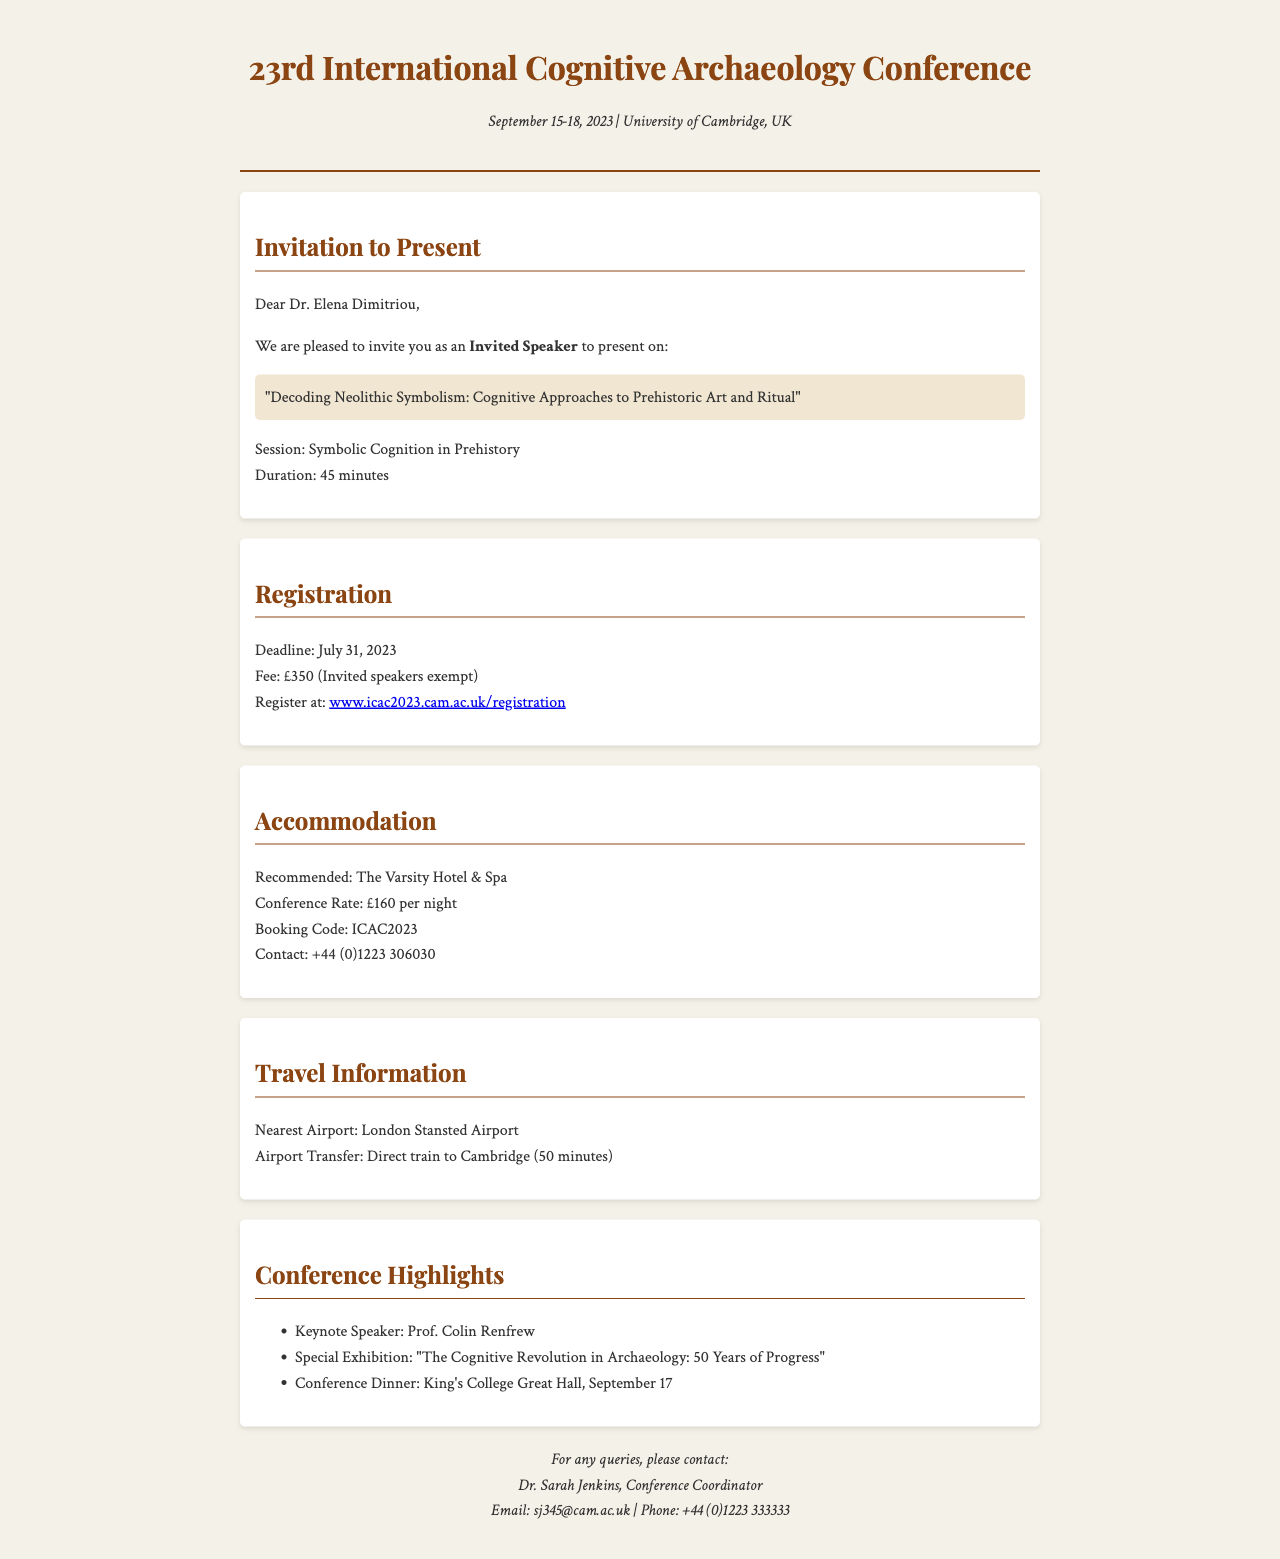What are the conference dates? The conference dates are specified in the document, which mentions September 15-18, 2023.
Answer: September 15-18, 2023 Who is invited to present at the conference? The document addresses an invitation to Dr. Elena Dimitriou, indicating she is the invited speaker.
Answer: Dr. Elena Dimitriou What is the title of the presentation? The document highlights the presentation title associated with the invited speaker, which is "Decoding Neolithic Symbolism: Cognitive Approaches to Prehistoric Art and Ritual".
Answer: Decoding Neolithic Symbolism: Cognitive Approaches to Prehistoric Art and Ritual What is the deadline for registration? The registration deadline is clearly stated in the document as July 31, 2023.
Answer: July 31, 2023 What is the conference rate for accommodation? The document mentions the conference rate for the recommended accommodation, which is £160 per night.
Answer: £160 per night How long is the presentation duration? The document specifies that the presentation duration is 45 minutes.
Answer: 45 minutes Which airport is nearest to the conference? The document identifies London Stansted Airport as the nearest airport to the University of Cambridge.
Answer: London Stansted Airport Who is the conference coordinator? The contact section of the document provides the name of the conference coordinator as Dr. Sarah Jenkins.
Answer: Dr. Sarah Jenkins 